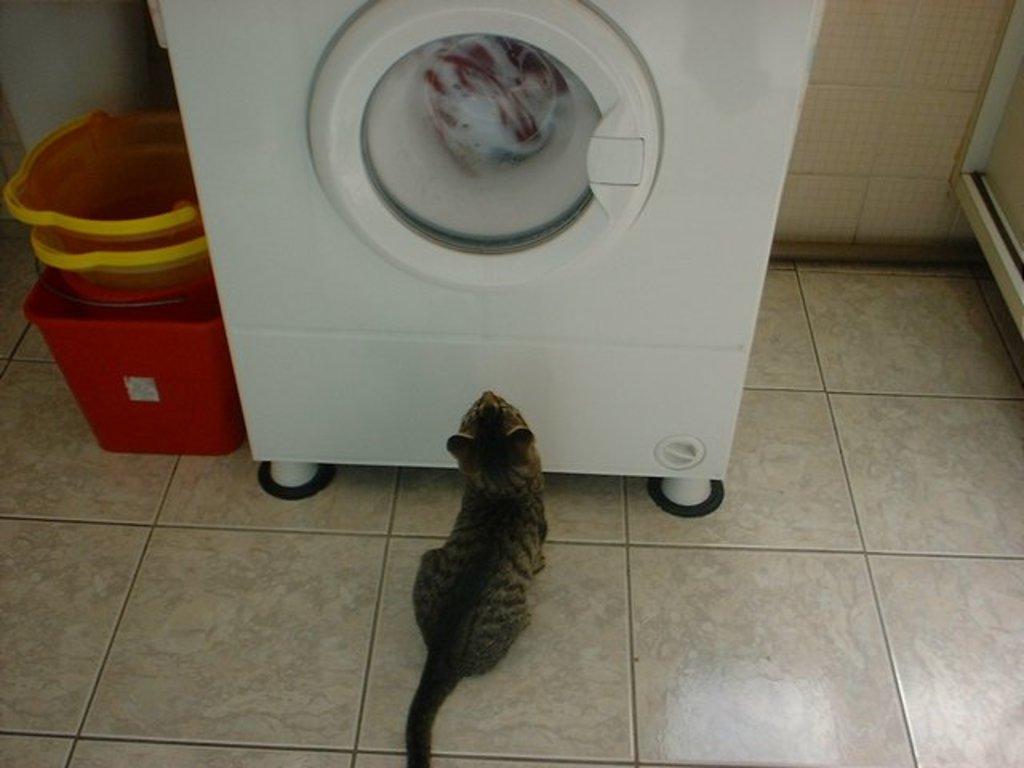Describe this image in one or two sentences. In this image I can see the washing machine which is in white color. In-front of the machine I can see a cat which is in black and grey color. To the left I can see some baskets which are in red and yellow color. I can see the wall in the back. 